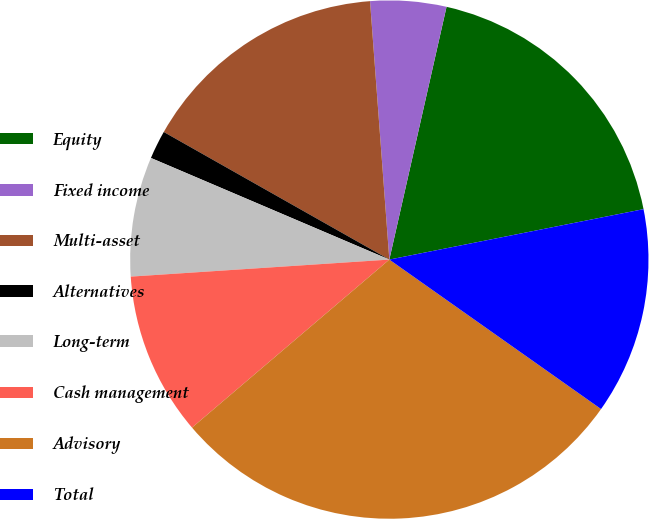Convert chart to OTSL. <chart><loc_0><loc_0><loc_500><loc_500><pie_chart><fcel>Equity<fcel>Fixed income<fcel>Multi-asset<fcel>Alternatives<fcel>Long-term<fcel>Cash management<fcel>Advisory<fcel>Total<nl><fcel>18.34%<fcel>4.73%<fcel>15.62%<fcel>1.78%<fcel>7.46%<fcel>10.18%<fcel>28.99%<fcel>12.9%<nl></chart> 